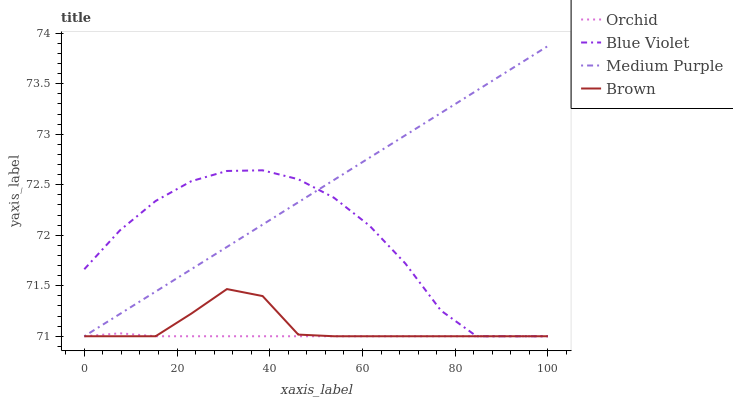Does Orchid have the minimum area under the curve?
Answer yes or no. Yes. Does Medium Purple have the maximum area under the curve?
Answer yes or no. Yes. Does Brown have the minimum area under the curve?
Answer yes or no. No. Does Brown have the maximum area under the curve?
Answer yes or no. No. Is Medium Purple the smoothest?
Answer yes or no. Yes. Is Blue Violet the roughest?
Answer yes or no. Yes. Is Brown the smoothest?
Answer yes or no. No. Is Brown the roughest?
Answer yes or no. No. Does Medium Purple have the lowest value?
Answer yes or no. Yes. Does Medium Purple have the highest value?
Answer yes or no. Yes. Does Brown have the highest value?
Answer yes or no. No. Does Brown intersect Medium Purple?
Answer yes or no. Yes. Is Brown less than Medium Purple?
Answer yes or no. No. Is Brown greater than Medium Purple?
Answer yes or no. No. 